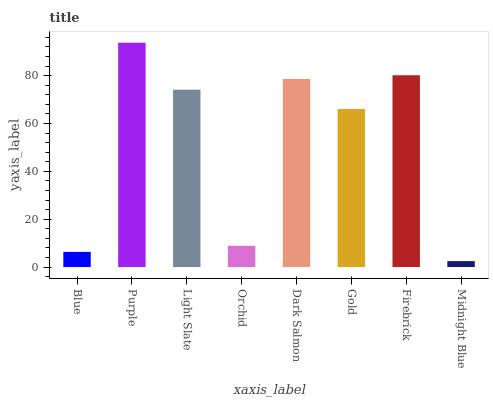Is Midnight Blue the minimum?
Answer yes or no. Yes. Is Purple the maximum?
Answer yes or no. Yes. Is Light Slate the minimum?
Answer yes or no. No. Is Light Slate the maximum?
Answer yes or no. No. Is Purple greater than Light Slate?
Answer yes or no. Yes. Is Light Slate less than Purple?
Answer yes or no. Yes. Is Light Slate greater than Purple?
Answer yes or no. No. Is Purple less than Light Slate?
Answer yes or no. No. Is Light Slate the high median?
Answer yes or no. Yes. Is Gold the low median?
Answer yes or no. Yes. Is Orchid the high median?
Answer yes or no. No. Is Purple the low median?
Answer yes or no. No. 